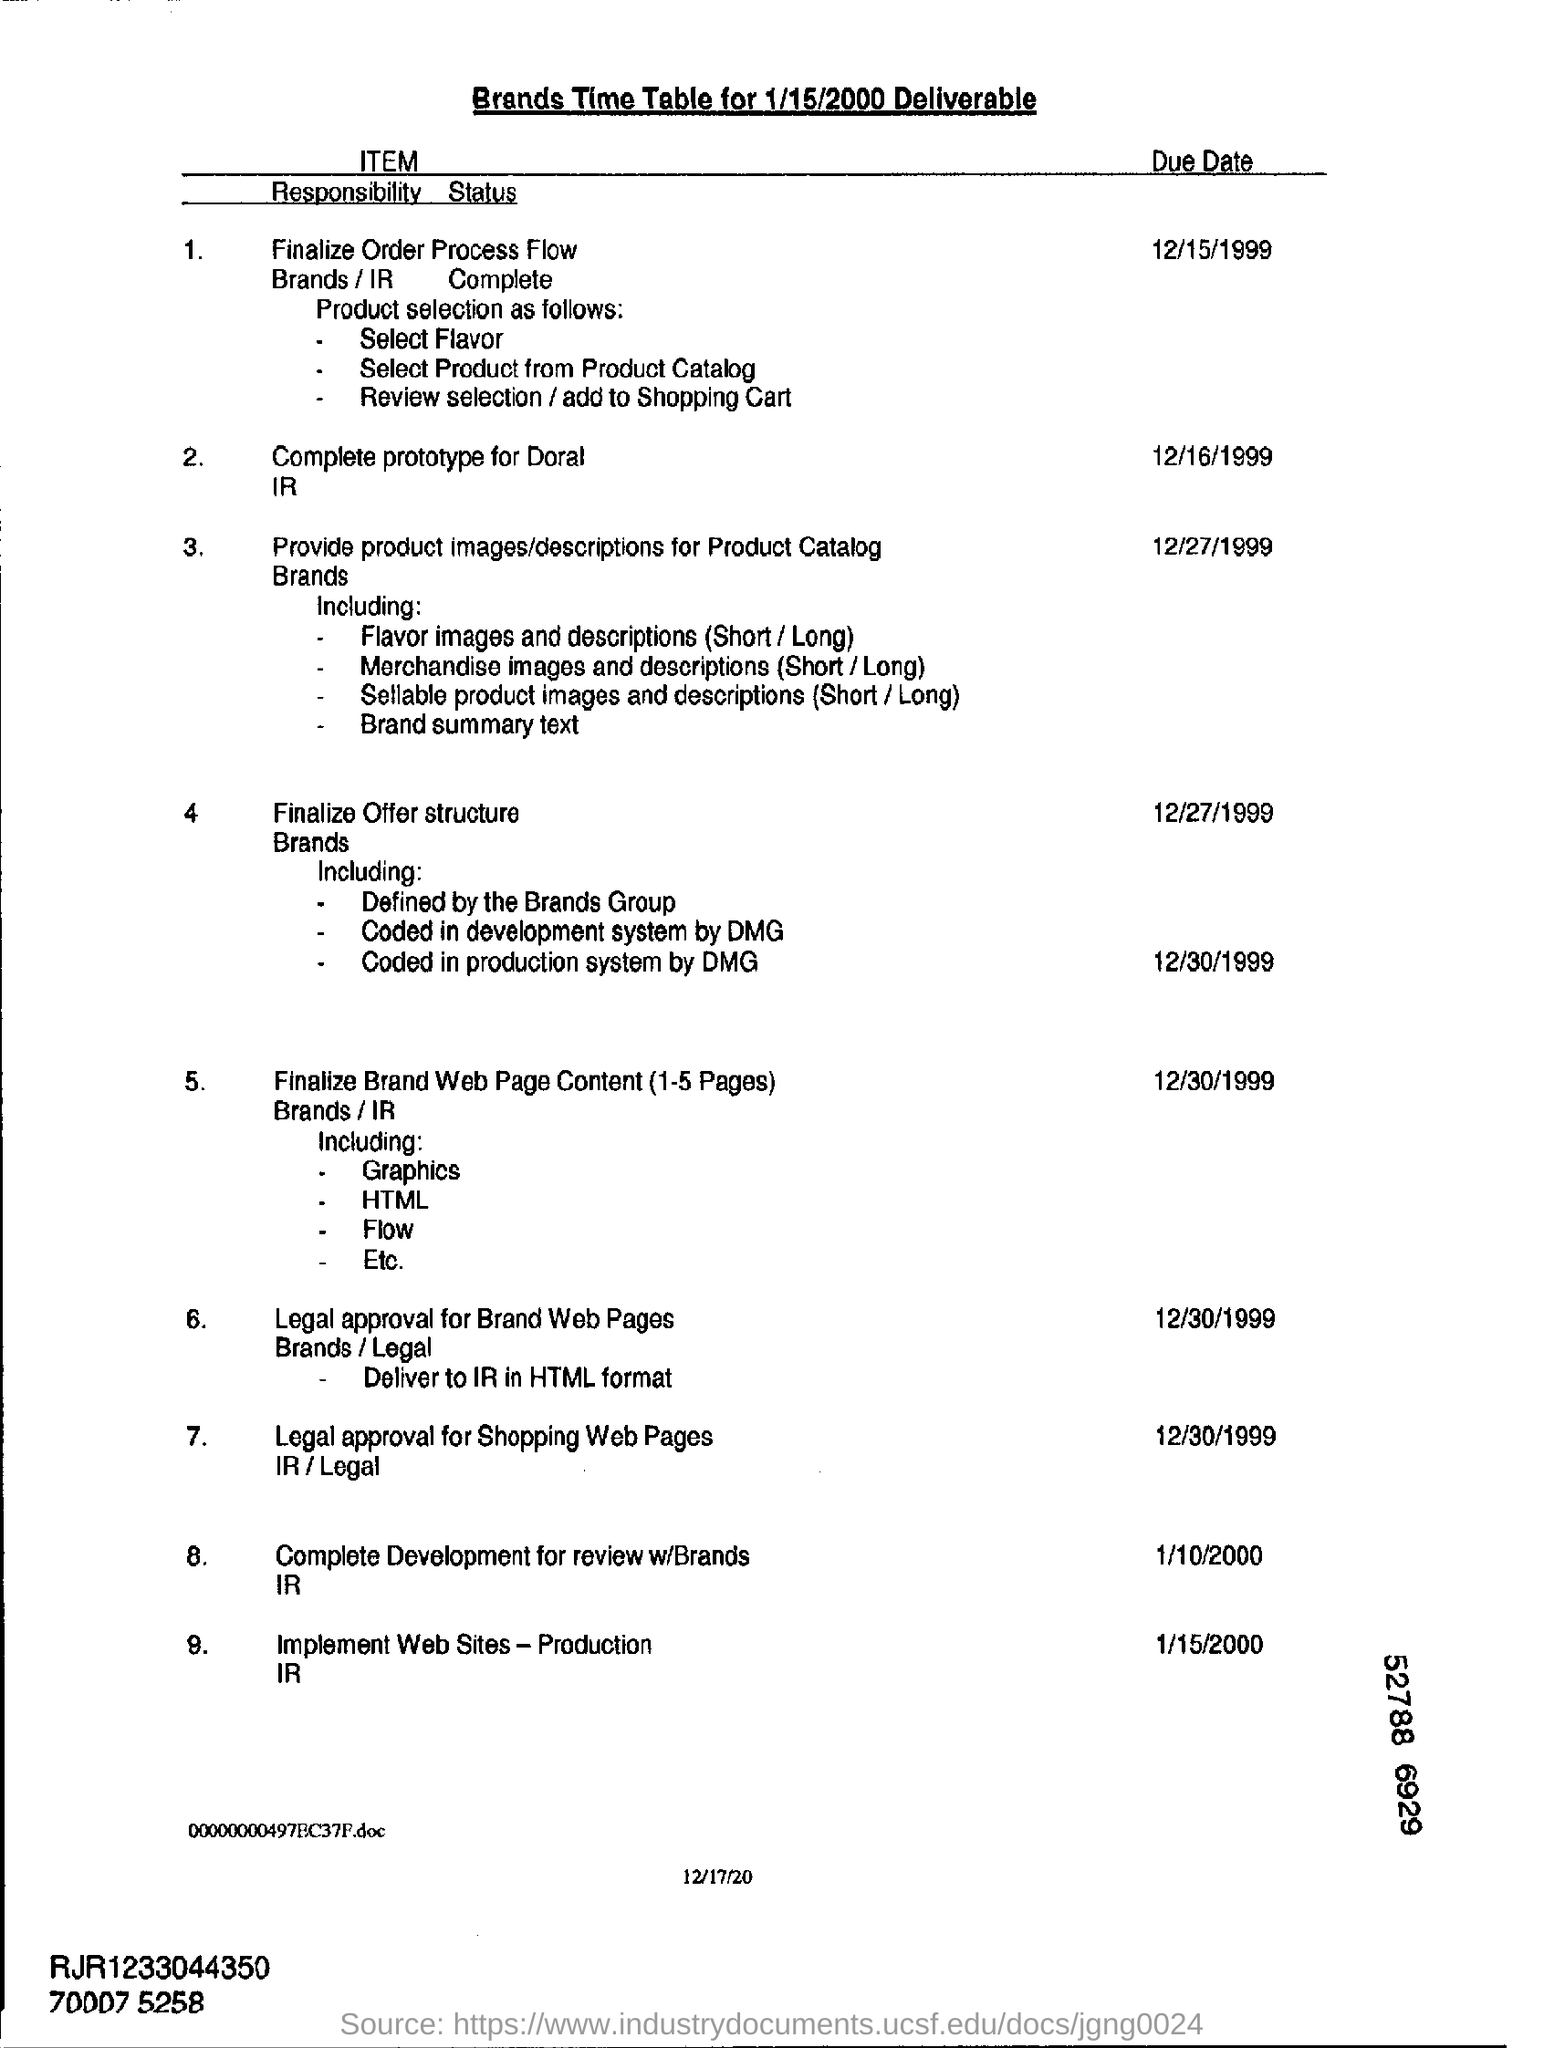What is the due date for complete prototype for doral ir?
Keep it short and to the point. 12/16/1999. Mention the date at bottom of the page ?
Give a very brief answer. 12/17/20. Mention the due date for implement web sites - production ir?
Your answer should be very brief. 1/15/2000. 